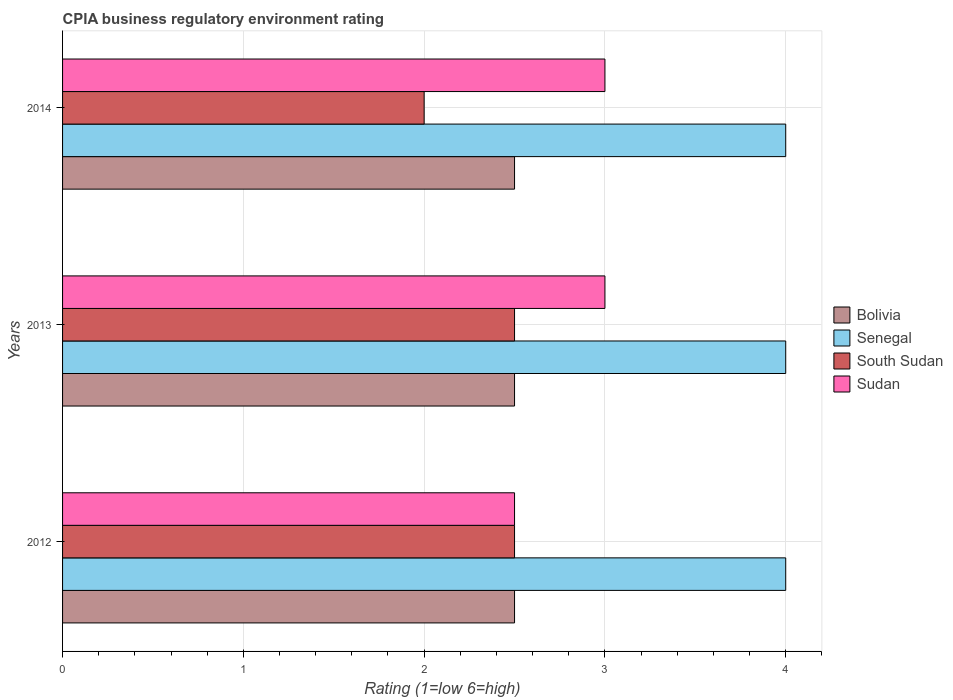Are the number of bars on each tick of the Y-axis equal?
Your answer should be compact. Yes. How many bars are there on the 3rd tick from the top?
Your response must be concise. 4. What is the label of the 2nd group of bars from the top?
Make the answer very short. 2013. In which year was the CPIA rating in Bolivia minimum?
Provide a succinct answer. 2012. What is the average CPIA rating in Sudan per year?
Offer a very short reply. 2.83. In the year 2012, what is the difference between the CPIA rating in South Sudan and CPIA rating in Bolivia?
Offer a very short reply. 0. In how many years, is the CPIA rating in Bolivia greater than 4 ?
Provide a succinct answer. 0. Is the difference between the CPIA rating in South Sudan in 2012 and 2014 greater than the difference between the CPIA rating in Bolivia in 2012 and 2014?
Ensure brevity in your answer.  Yes. What is the difference between the highest and the lowest CPIA rating in Senegal?
Make the answer very short. 0. In how many years, is the CPIA rating in Senegal greater than the average CPIA rating in Senegal taken over all years?
Your answer should be compact. 0. Is the sum of the CPIA rating in Bolivia in 2012 and 2014 greater than the maximum CPIA rating in Senegal across all years?
Make the answer very short. Yes. What does the 1st bar from the top in 2013 represents?
Offer a very short reply. Sudan. Is it the case that in every year, the sum of the CPIA rating in Senegal and CPIA rating in Sudan is greater than the CPIA rating in South Sudan?
Ensure brevity in your answer.  Yes. How many bars are there?
Your answer should be very brief. 12. How many years are there in the graph?
Keep it short and to the point. 3. Where does the legend appear in the graph?
Keep it short and to the point. Center right. How many legend labels are there?
Offer a terse response. 4. What is the title of the graph?
Keep it short and to the point. CPIA business regulatory environment rating. What is the label or title of the X-axis?
Ensure brevity in your answer.  Rating (1=low 6=high). What is the Rating (1=low 6=high) of Bolivia in 2012?
Your response must be concise. 2.5. What is the Rating (1=low 6=high) in Senegal in 2012?
Ensure brevity in your answer.  4. What is the Rating (1=low 6=high) of South Sudan in 2012?
Provide a succinct answer. 2.5. What is the Rating (1=low 6=high) of Senegal in 2013?
Make the answer very short. 4. What is the Rating (1=low 6=high) in South Sudan in 2013?
Make the answer very short. 2.5. What is the Rating (1=low 6=high) of Senegal in 2014?
Your response must be concise. 4. What is the Rating (1=low 6=high) of Sudan in 2014?
Provide a succinct answer. 3. What is the total Rating (1=low 6=high) of Bolivia in the graph?
Keep it short and to the point. 7.5. What is the total Rating (1=low 6=high) of South Sudan in the graph?
Your answer should be very brief. 7. What is the difference between the Rating (1=low 6=high) of Sudan in 2012 and that in 2013?
Make the answer very short. -0.5. What is the difference between the Rating (1=low 6=high) in Senegal in 2012 and that in 2014?
Give a very brief answer. 0. What is the difference between the Rating (1=low 6=high) in South Sudan in 2012 and that in 2014?
Make the answer very short. 0.5. What is the difference between the Rating (1=low 6=high) in Bolivia in 2012 and the Rating (1=low 6=high) in Senegal in 2013?
Give a very brief answer. -1.5. What is the difference between the Rating (1=low 6=high) of Bolivia in 2012 and the Rating (1=low 6=high) of Sudan in 2013?
Offer a very short reply. -0.5. What is the difference between the Rating (1=low 6=high) in Senegal in 2012 and the Rating (1=low 6=high) in Sudan in 2013?
Provide a succinct answer. 1. What is the difference between the Rating (1=low 6=high) of Bolivia in 2012 and the Rating (1=low 6=high) of South Sudan in 2014?
Your response must be concise. 0.5. What is the difference between the Rating (1=low 6=high) in Bolivia in 2012 and the Rating (1=low 6=high) in Sudan in 2014?
Keep it short and to the point. -0.5. What is the difference between the Rating (1=low 6=high) in Senegal in 2012 and the Rating (1=low 6=high) in South Sudan in 2014?
Your answer should be very brief. 2. What is the difference between the Rating (1=low 6=high) in South Sudan in 2012 and the Rating (1=low 6=high) in Sudan in 2014?
Keep it short and to the point. -0.5. What is the difference between the Rating (1=low 6=high) in Bolivia in 2013 and the Rating (1=low 6=high) in South Sudan in 2014?
Offer a terse response. 0.5. What is the average Rating (1=low 6=high) in Bolivia per year?
Keep it short and to the point. 2.5. What is the average Rating (1=low 6=high) in South Sudan per year?
Give a very brief answer. 2.33. What is the average Rating (1=low 6=high) in Sudan per year?
Your response must be concise. 2.83. In the year 2012, what is the difference between the Rating (1=low 6=high) in Bolivia and Rating (1=low 6=high) in Senegal?
Offer a very short reply. -1.5. In the year 2012, what is the difference between the Rating (1=low 6=high) of Bolivia and Rating (1=low 6=high) of South Sudan?
Make the answer very short. 0. In the year 2012, what is the difference between the Rating (1=low 6=high) of Bolivia and Rating (1=low 6=high) of Sudan?
Give a very brief answer. 0. In the year 2012, what is the difference between the Rating (1=low 6=high) of Senegal and Rating (1=low 6=high) of South Sudan?
Ensure brevity in your answer.  1.5. In the year 2012, what is the difference between the Rating (1=low 6=high) of South Sudan and Rating (1=low 6=high) of Sudan?
Offer a very short reply. 0. In the year 2013, what is the difference between the Rating (1=low 6=high) of Senegal and Rating (1=low 6=high) of South Sudan?
Provide a succinct answer. 1.5. In the year 2013, what is the difference between the Rating (1=low 6=high) in Senegal and Rating (1=low 6=high) in Sudan?
Give a very brief answer. 1. In the year 2013, what is the difference between the Rating (1=low 6=high) of South Sudan and Rating (1=low 6=high) of Sudan?
Keep it short and to the point. -0.5. In the year 2014, what is the difference between the Rating (1=low 6=high) of Bolivia and Rating (1=low 6=high) of South Sudan?
Your response must be concise. 0.5. In the year 2014, what is the difference between the Rating (1=low 6=high) in Senegal and Rating (1=low 6=high) in South Sudan?
Offer a very short reply. 2. In the year 2014, what is the difference between the Rating (1=low 6=high) in Senegal and Rating (1=low 6=high) in Sudan?
Provide a short and direct response. 1. What is the ratio of the Rating (1=low 6=high) of Bolivia in 2012 to that in 2013?
Ensure brevity in your answer.  1. What is the ratio of the Rating (1=low 6=high) in South Sudan in 2012 to that in 2013?
Your answer should be very brief. 1. What is the ratio of the Rating (1=low 6=high) in Senegal in 2012 to that in 2014?
Your answer should be compact. 1. What is the ratio of the Rating (1=low 6=high) of Sudan in 2012 to that in 2014?
Make the answer very short. 0.83. What is the ratio of the Rating (1=low 6=high) of Bolivia in 2013 to that in 2014?
Offer a terse response. 1. What is the ratio of the Rating (1=low 6=high) in Senegal in 2013 to that in 2014?
Give a very brief answer. 1. What is the difference between the highest and the second highest Rating (1=low 6=high) of Senegal?
Your answer should be compact. 0. What is the difference between the highest and the second highest Rating (1=low 6=high) in South Sudan?
Make the answer very short. 0. What is the difference between the highest and the lowest Rating (1=low 6=high) in Bolivia?
Provide a succinct answer. 0. What is the difference between the highest and the lowest Rating (1=low 6=high) in Senegal?
Your response must be concise. 0. 